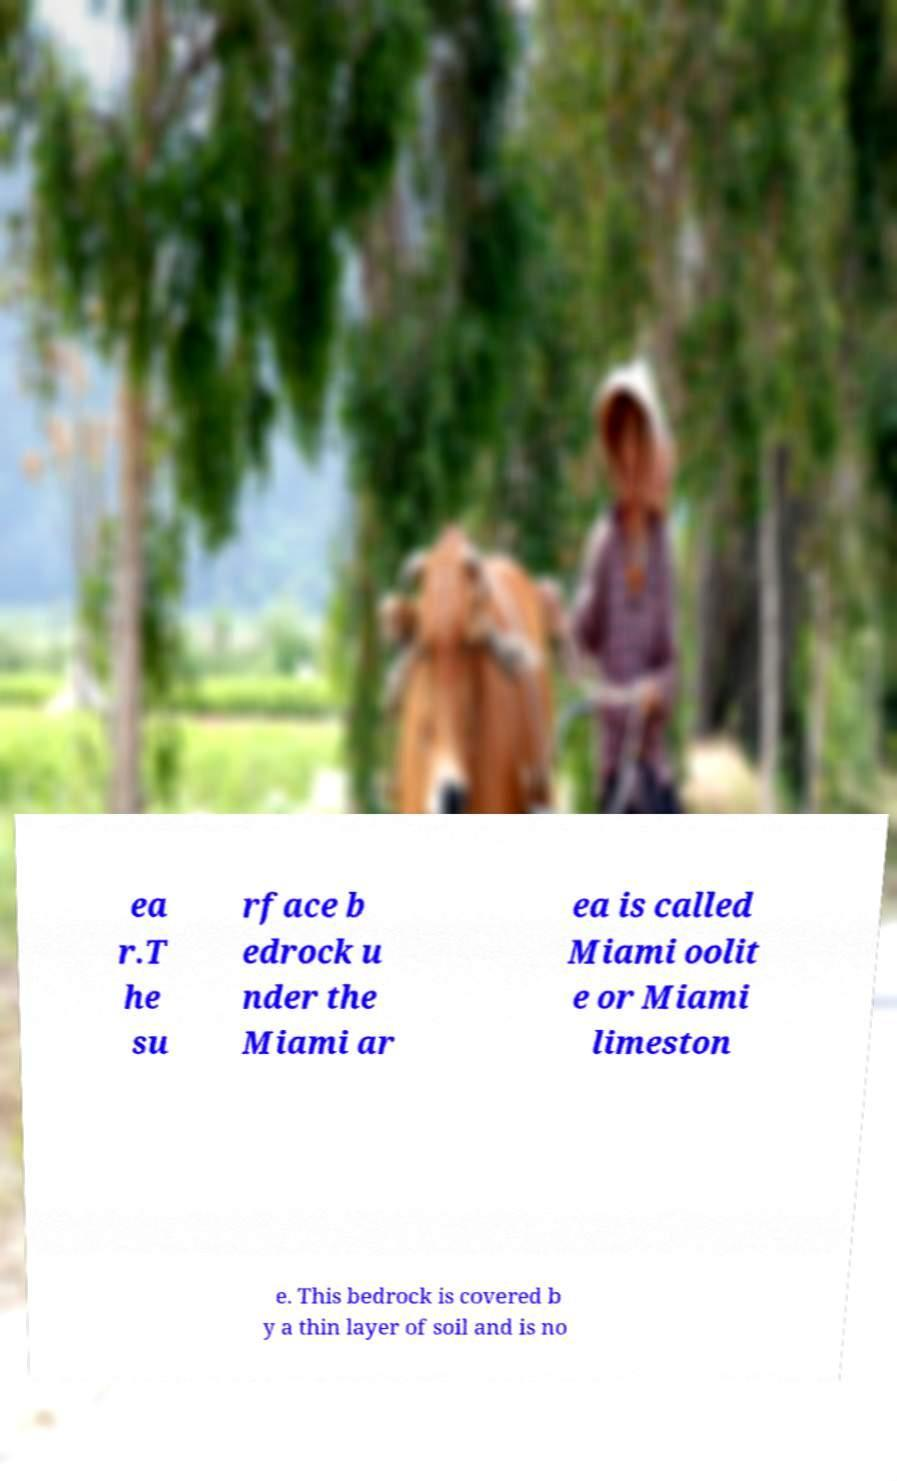Could you assist in decoding the text presented in this image and type it out clearly? ea r.T he su rface b edrock u nder the Miami ar ea is called Miami oolit e or Miami limeston e. This bedrock is covered b y a thin layer of soil and is no 